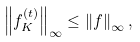Convert formula to latex. <formula><loc_0><loc_0><loc_500><loc_500>\left \| f _ { K } ^ { ( t ) } \right \| _ { \infty } \leq \left \| f \right \| _ { \infty } ,</formula> 